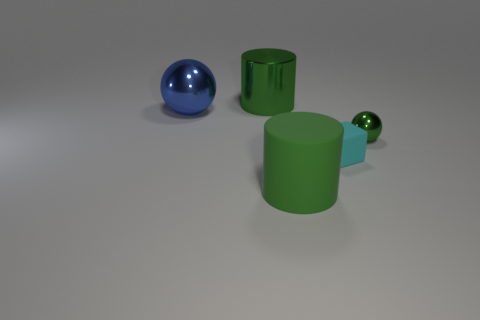Add 3 small gray metal spheres. How many objects exist? 8 Add 2 cyan blocks. How many cyan blocks exist? 3 Subtract 1 cyan blocks. How many objects are left? 4 Subtract all blocks. How many objects are left? 4 Subtract 1 cubes. How many cubes are left? 0 Subtract all cyan spheres. Subtract all yellow cylinders. How many spheres are left? 2 Subtract all cyan cylinders. How many red balls are left? 0 Subtract all big things. Subtract all matte cylinders. How many objects are left? 1 Add 4 tiny cyan matte blocks. How many tiny cyan matte blocks are left? 5 